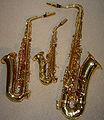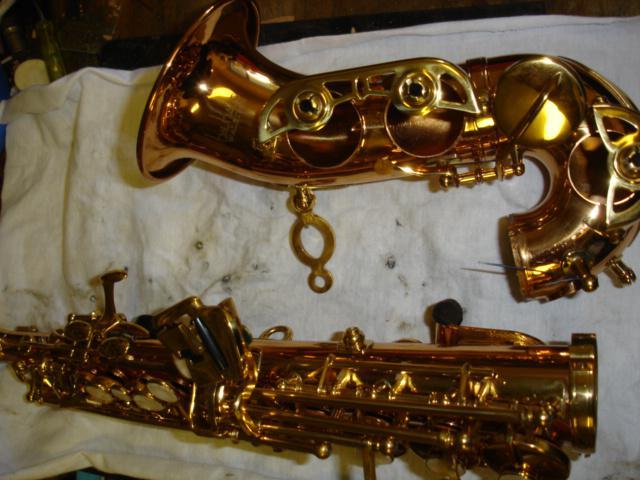The first image is the image on the left, the second image is the image on the right. For the images displayed, is the sentence "A saxophone is on a stand in the right image." factually correct? Answer yes or no. No. The first image is the image on the left, the second image is the image on the right. For the images shown, is this caption "An image shows a brass-colored saxophone held upright on a blacks stand." true? Answer yes or no. No. 